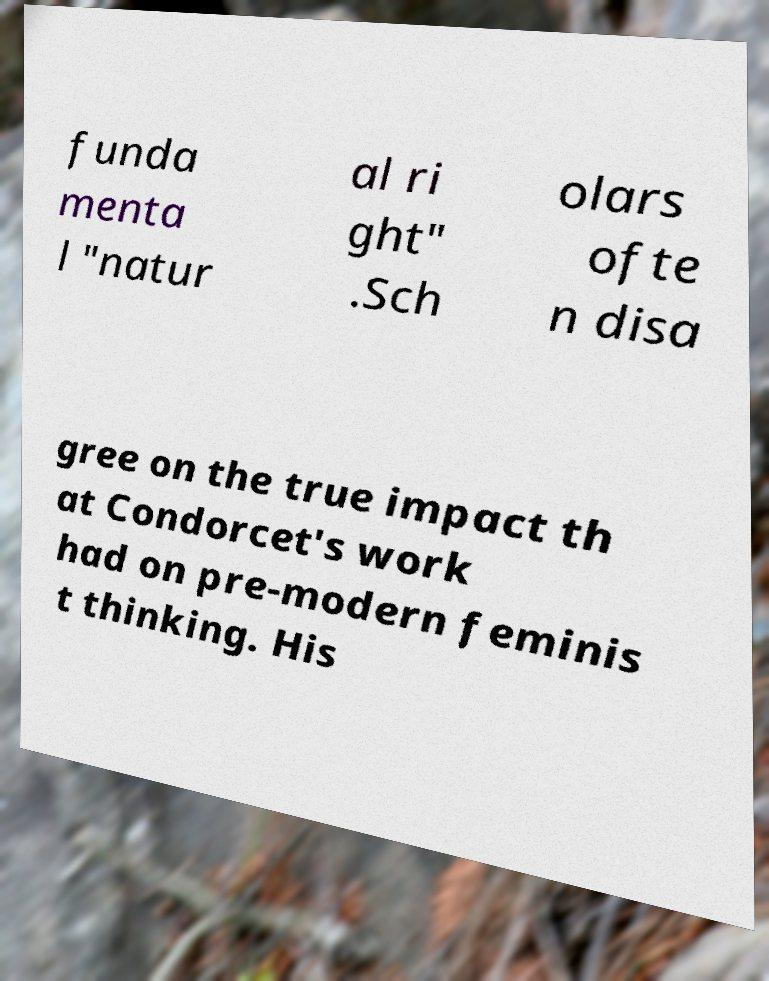Please read and relay the text visible in this image. What does it say? funda menta l "natur al ri ght" .Sch olars ofte n disa gree on the true impact th at Condorcet's work had on pre-modern feminis t thinking. His 